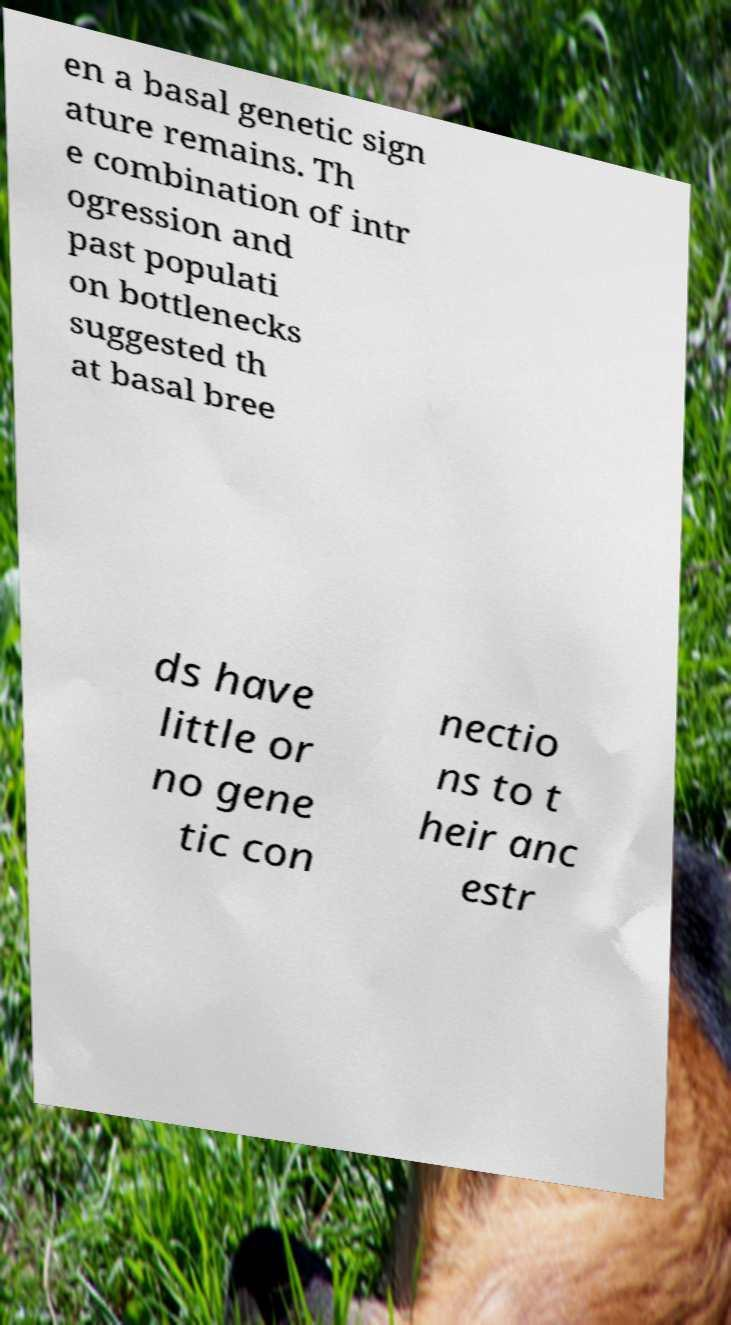Could you assist in decoding the text presented in this image and type it out clearly? en a basal genetic sign ature remains. Th e combination of intr ogression and past populati on bottlenecks suggested th at basal bree ds have little or no gene tic con nectio ns to t heir anc estr 